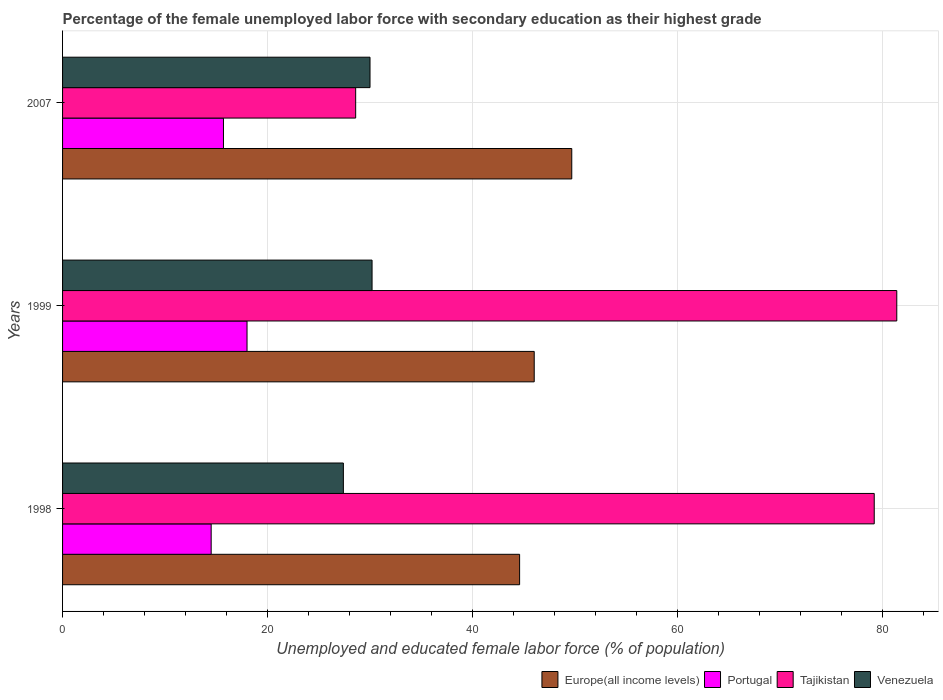How many different coloured bars are there?
Ensure brevity in your answer.  4. Are the number of bars on each tick of the Y-axis equal?
Make the answer very short. Yes. How many bars are there on the 2nd tick from the bottom?
Your answer should be very brief. 4. What is the percentage of the unemployed female labor force with secondary education in Tajikistan in 2007?
Ensure brevity in your answer.  28.6. Across all years, what is the minimum percentage of the unemployed female labor force with secondary education in Venezuela?
Provide a succinct answer. 27.4. What is the total percentage of the unemployed female labor force with secondary education in Portugal in the graph?
Offer a very short reply. 48.2. What is the difference between the percentage of the unemployed female labor force with secondary education in Venezuela in 1998 and that in 1999?
Ensure brevity in your answer.  -2.8. What is the difference between the percentage of the unemployed female labor force with secondary education in Tajikistan in 1998 and the percentage of the unemployed female labor force with secondary education in Europe(all income levels) in 1999?
Ensure brevity in your answer.  33.18. What is the average percentage of the unemployed female labor force with secondary education in Venezuela per year?
Offer a terse response. 29.2. In the year 1999, what is the difference between the percentage of the unemployed female labor force with secondary education in Tajikistan and percentage of the unemployed female labor force with secondary education in Venezuela?
Offer a very short reply. 51.2. In how many years, is the percentage of the unemployed female labor force with secondary education in Venezuela greater than 40 %?
Ensure brevity in your answer.  0. What is the ratio of the percentage of the unemployed female labor force with secondary education in Portugal in 1999 to that in 2007?
Ensure brevity in your answer.  1.15. Is the percentage of the unemployed female labor force with secondary education in Portugal in 1999 less than that in 2007?
Give a very brief answer. No. Is the difference between the percentage of the unemployed female labor force with secondary education in Tajikistan in 1998 and 1999 greater than the difference between the percentage of the unemployed female labor force with secondary education in Venezuela in 1998 and 1999?
Your response must be concise. Yes. What is the difference between the highest and the second highest percentage of the unemployed female labor force with secondary education in Europe(all income levels)?
Offer a very short reply. 3.66. What is the difference between the highest and the lowest percentage of the unemployed female labor force with secondary education in Tajikistan?
Keep it short and to the point. 52.8. In how many years, is the percentage of the unemployed female labor force with secondary education in Venezuela greater than the average percentage of the unemployed female labor force with secondary education in Venezuela taken over all years?
Offer a terse response. 2. Is it the case that in every year, the sum of the percentage of the unemployed female labor force with secondary education in Tajikistan and percentage of the unemployed female labor force with secondary education in Portugal is greater than the sum of percentage of the unemployed female labor force with secondary education in Europe(all income levels) and percentage of the unemployed female labor force with secondary education in Venezuela?
Provide a short and direct response. No. What does the 4th bar from the top in 1998 represents?
Give a very brief answer. Europe(all income levels). What does the 3rd bar from the bottom in 2007 represents?
Your response must be concise. Tajikistan. Is it the case that in every year, the sum of the percentage of the unemployed female labor force with secondary education in Portugal and percentage of the unemployed female labor force with secondary education in Tajikistan is greater than the percentage of the unemployed female labor force with secondary education in Venezuela?
Offer a very short reply. Yes. How many bars are there?
Make the answer very short. 12. What is the difference between two consecutive major ticks on the X-axis?
Provide a short and direct response. 20. Does the graph contain any zero values?
Provide a short and direct response. No. How are the legend labels stacked?
Make the answer very short. Horizontal. What is the title of the graph?
Keep it short and to the point. Percentage of the female unemployed labor force with secondary education as their highest grade. What is the label or title of the X-axis?
Your answer should be very brief. Unemployed and educated female labor force (% of population). What is the Unemployed and educated female labor force (% of population) of Europe(all income levels) in 1998?
Make the answer very short. 44.6. What is the Unemployed and educated female labor force (% of population) of Portugal in 1998?
Give a very brief answer. 14.5. What is the Unemployed and educated female labor force (% of population) of Tajikistan in 1998?
Give a very brief answer. 79.2. What is the Unemployed and educated female labor force (% of population) of Venezuela in 1998?
Offer a very short reply. 27.4. What is the Unemployed and educated female labor force (% of population) in Europe(all income levels) in 1999?
Provide a short and direct response. 46.02. What is the Unemployed and educated female labor force (% of population) in Tajikistan in 1999?
Your answer should be compact. 81.4. What is the Unemployed and educated female labor force (% of population) in Venezuela in 1999?
Your response must be concise. 30.2. What is the Unemployed and educated female labor force (% of population) in Europe(all income levels) in 2007?
Provide a short and direct response. 49.69. What is the Unemployed and educated female labor force (% of population) of Portugal in 2007?
Keep it short and to the point. 15.7. What is the Unemployed and educated female labor force (% of population) of Tajikistan in 2007?
Your response must be concise. 28.6. Across all years, what is the maximum Unemployed and educated female labor force (% of population) of Europe(all income levels)?
Ensure brevity in your answer.  49.69. Across all years, what is the maximum Unemployed and educated female labor force (% of population) in Tajikistan?
Ensure brevity in your answer.  81.4. Across all years, what is the maximum Unemployed and educated female labor force (% of population) of Venezuela?
Ensure brevity in your answer.  30.2. Across all years, what is the minimum Unemployed and educated female labor force (% of population) in Europe(all income levels)?
Give a very brief answer. 44.6. Across all years, what is the minimum Unemployed and educated female labor force (% of population) of Portugal?
Ensure brevity in your answer.  14.5. Across all years, what is the minimum Unemployed and educated female labor force (% of population) of Tajikistan?
Ensure brevity in your answer.  28.6. Across all years, what is the minimum Unemployed and educated female labor force (% of population) of Venezuela?
Keep it short and to the point. 27.4. What is the total Unemployed and educated female labor force (% of population) in Europe(all income levels) in the graph?
Keep it short and to the point. 140.31. What is the total Unemployed and educated female labor force (% of population) in Portugal in the graph?
Provide a short and direct response. 48.2. What is the total Unemployed and educated female labor force (% of population) in Tajikistan in the graph?
Provide a succinct answer. 189.2. What is the total Unemployed and educated female labor force (% of population) in Venezuela in the graph?
Your answer should be compact. 87.6. What is the difference between the Unemployed and educated female labor force (% of population) in Europe(all income levels) in 1998 and that in 1999?
Offer a terse response. -1.43. What is the difference between the Unemployed and educated female labor force (% of population) of Portugal in 1998 and that in 1999?
Ensure brevity in your answer.  -3.5. What is the difference between the Unemployed and educated female labor force (% of population) of Venezuela in 1998 and that in 1999?
Provide a succinct answer. -2.8. What is the difference between the Unemployed and educated female labor force (% of population) in Europe(all income levels) in 1998 and that in 2007?
Keep it short and to the point. -5.09. What is the difference between the Unemployed and educated female labor force (% of population) of Portugal in 1998 and that in 2007?
Your answer should be very brief. -1.2. What is the difference between the Unemployed and educated female labor force (% of population) of Tajikistan in 1998 and that in 2007?
Keep it short and to the point. 50.6. What is the difference between the Unemployed and educated female labor force (% of population) in Venezuela in 1998 and that in 2007?
Offer a terse response. -2.6. What is the difference between the Unemployed and educated female labor force (% of population) in Europe(all income levels) in 1999 and that in 2007?
Keep it short and to the point. -3.66. What is the difference between the Unemployed and educated female labor force (% of population) of Portugal in 1999 and that in 2007?
Make the answer very short. 2.3. What is the difference between the Unemployed and educated female labor force (% of population) of Tajikistan in 1999 and that in 2007?
Offer a very short reply. 52.8. What is the difference between the Unemployed and educated female labor force (% of population) of Europe(all income levels) in 1998 and the Unemployed and educated female labor force (% of population) of Portugal in 1999?
Keep it short and to the point. 26.6. What is the difference between the Unemployed and educated female labor force (% of population) of Europe(all income levels) in 1998 and the Unemployed and educated female labor force (% of population) of Tajikistan in 1999?
Your answer should be very brief. -36.8. What is the difference between the Unemployed and educated female labor force (% of population) of Europe(all income levels) in 1998 and the Unemployed and educated female labor force (% of population) of Venezuela in 1999?
Give a very brief answer. 14.4. What is the difference between the Unemployed and educated female labor force (% of population) in Portugal in 1998 and the Unemployed and educated female labor force (% of population) in Tajikistan in 1999?
Your answer should be very brief. -66.9. What is the difference between the Unemployed and educated female labor force (% of population) of Portugal in 1998 and the Unemployed and educated female labor force (% of population) of Venezuela in 1999?
Offer a terse response. -15.7. What is the difference between the Unemployed and educated female labor force (% of population) in Tajikistan in 1998 and the Unemployed and educated female labor force (% of population) in Venezuela in 1999?
Keep it short and to the point. 49. What is the difference between the Unemployed and educated female labor force (% of population) of Europe(all income levels) in 1998 and the Unemployed and educated female labor force (% of population) of Portugal in 2007?
Your answer should be very brief. 28.9. What is the difference between the Unemployed and educated female labor force (% of population) in Europe(all income levels) in 1998 and the Unemployed and educated female labor force (% of population) in Tajikistan in 2007?
Your response must be concise. 16. What is the difference between the Unemployed and educated female labor force (% of population) of Europe(all income levels) in 1998 and the Unemployed and educated female labor force (% of population) of Venezuela in 2007?
Provide a short and direct response. 14.6. What is the difference between the Unemployed and educated female labor force (% of population) of Portugal in 1998 and the Unemployed and educated female labor force (% of population) of Tajikistan in 2007?
Provide a short and direct response. -14.1. What is the difference between the Unemployed and educated female labor force (% of population) in Portugal in 1998 and the Unemployed and educated female labor force (% of population) in Venezuela in 2007?
Your answer should be compact. -15.5. What is the difference between the Unemployed and educated female labor force (% of population) in Tajikistan in 1998 and the Unemployed and educated female labor force (% of population) in Venezuela in 2007?
Ensure brevity in your answer.  49.2. What is the difference between the Unemployed and educated female labor force (% of population) in Europe(all income levels) in 1999 and the Unemployed and educated female labor force (% of population) in Portugal in 2007?
Ensure brevity in your answer.  30.32. What is the difference between the Unemployed and educated female labor force (% of population) of Europe(all income levels) in 1999 and the Unemployed and educated female labor force (% of population) of Tajikistan in 2007?
Make the answer very short. 17.42. What is the difference between the Unemployed and educated female labor force (% of population) of Europe(all income levels) in 1999 and the Unemployed and educated female labor force (% of population) of Venezuela in 2007?
Give a very brief answer. 16.02. What is the difference between the Unemployed and educated female labor force (% of population) of Portugal in 1999 and the Unemployed and educated female labor force (% of population) of Tajikistan in 2007?
Provide a succinct answer. -10.6. What is the difference between the Unemployed and educated female labor force (% of population) in Tajikistan in 1999 and the Unemployed and educated female labor force (% of population) in Venezuela in 2007?
Your response must be concise. 51.4. What is the average Unemployed and educated female labor force (% of population) in Europe(all income levels) per year?
Make the answer very short. 46.77. What is the average Unemployed and educated female labor force (% of population) in Portugal per year?
Offer a terse response. 16.07. What is the average Unemployed and educated female labor force (% of population) of Tajikistan per year?
Give a very brief answer. 63.07. What is the average Unemployed and educated female labor force (% of population) of Venezuela per year?
Provide a short and direct response. 29.2. In the year 1998, what is the difference between the Unemployed and educated female labor force (% of population) of Europe(all income levels) and Unemployed and educated female labor force (% of population) of Portugal?
Your answer should be very brief. 30.1. In the year 1998, what is the difference between the Unemployed and educated female labor force (% of population) in Europe(all income levels) and Unemployed and educated female labor force (% of population) in Tajikistan?
Ensure brevity in your answer.  -34.6. In the year 1998, what is the difference between the Unemployed and educated female labor force (% of population) in Europe(all income levels) and Unemployed and educated female labor force (% of population) in Venezuela?
Your answer should be very brief. 17.2. In the year 1998, what is the difference between the Unemployed and educated female labor force (% of population) in Portugal and Unemployed and educated female labor force (% of population) in Tajikistan?
Offer a very short reply. -64.7. In the year 1998, what is the difference between the Unemployed and educated female labor force (% of population) of Tajikistan and Unemployed and educated female labor force (% of population) of Venezuela?
Ensure brevity in your answer.  51.8. In the year 1999, what is the difference between the Unemployed and educated female labor force (% of population) in Europe(all income levels) and Unemployed and educated female labor force (% of population) in Portugal?
Make the answer very short. 28.02. In the year 1999, what is the difference between the Unemployed and educated female labor force (% of population) of Europe(all income levels) and Unemployed and educated female labor force (% of population) of Tajikistan?
Offer a very short reply. -35.38. In the year 1999, what is the difference between the Unemployed and educated female labor force (% of population) in Europe(all income levels) and Unemployed and educated female labor force (% of population) in Venezuela?
Give a very brief answer. 15.82. In the year 1999, what is the difference between the Unemployed and educated female labor force (% of population) of Portugal and Unemployed and educated female labor force (% of population) of Tajikistan?
Provide a succinct answer. -63.4. In the year 1999, what is the difference between the Unemployed and educated female labor force (% of population) in Portugal and Unemployed and educated female labor force (% of population) in Venezuela?
Offer a very short reply. -12.2. In the year 1999, what is the difference between the Unemployed and educated female labor force (% of population) in Tajikistan and Unemployed and educated female labor force (% of population) in Venezuela?
Offer a very short reply. 51.2. In the year 2007, what is the difference between the Unemployed and educated female labor force (% of population) of Europe(all income levels) and Unemployed and educated female labor force (% of population) of Portugal?
Make the answer very short. 33.99. In the year 2007, what is the difference between the Unemployed and educated female labor force (% of population) in Europe(all income levels) and Unemployed and educated female labor force (% of population) in Tajikistan?
Offer a terse response. 21.09. In the year 2007, what is the difference between the Unemployed and educated female labor force (% of population) of Europe(all income levels) and Unemployed and educated female labor force (% of population) of Venezuela?
Your response must be concise. 19.69. In the year 2007, what is the difference between the Unemployed and educated female labor force (% of population) in Portugal and Unemployed and educated female labor force (% of population) in Tajikistan?
Give a very brief answer. -12.9. In the year 2007, what is the difference between the Unemployed and educated female labor force (% of population) of Portugal and Unemployed and educated female labor force (% of population) of Venezuela?
Make the answer very short. -14.3. In the year 2007, what is the difference between the Unemployed and educated female labor force (% of population) of Tajikistan and Unemployed and educated female labor force (% of population) of Venezuela?
Provide a short and direct response. -1.4. What is the ratio of the Unemployed and educated female labor force (% of population) in Portugal in 1998 to that in 1999?
Your answer should be very brief. 0.81. What is the ratio of the Unemployed and educated female labor force (% of population) of Venezuela in 1998 to that in 1999?
Ensure brevity in your answer.  0.91. What is the ratio of the Unemployed and educated female labor force (% of population) of Europe(all income levels) in 1998 to that in 2007?
Make the answer very short. 0.9. What is the ratio of the Unemployed and educated female labor force (% of population) of Portugal in 1998 to that in 2007?
Give a very brief answer. 0.92. What is the ratio of the Unemployed and educated female labor force (% of population) in Tajikistan in 1998 to that in 2007?
Ensure brevity in your answer.  2.77. What is the ratio of the Unemployed and educated female labor force (% of population) of Venezuela in 1998 to that in 2007?
Your answer should be compact. 0.91. What is the ratio of the Unemployed and educated female labor force (% of population) in Europe(all income levels) in 1999 to that in 2007?
Give a very brief answer. 0.93. What is the ratio of the Unemployed and educated female labor force (% of population) of Portugal in 1999 to that in 2007?
Your answer should be compact. 1.15. What is the ratio of the Unemployed and educated female labor force (% of population) in Tajikistan in 1999 to that in 2007?
Offer a very short reply. 2.85. What is the difference between the highest and the second highest Unemployed and educated female labor force (% of population) of Europe(all income levels)?
Make the answer very short. 3.66. What is the difference between the highest and the second highest Unemployed and educated female labor force (% of population) in Venezuela?
Provide a short and direct response. 0.2. What is the difference between the highest and the lowest Unemployed and educated female labor force (% of population) in Europe(all income levels)?
Keep it short and to the point. 5.09. What is the difference between the highest and the lowest Unemployed and educated female labor force (% of population) in Portugal?
Your answer should be compact. 3.5. What is the difference between the highest and the lowest Unemployed and educated female labor force (% of population) in Tajikistan?
Provide a short and direct response. 52.8. What is the difference between the highest and the lowest Unemployed and educated female labor force (% of population) of Venezuela?
Give a very brief answer. 2.8. 